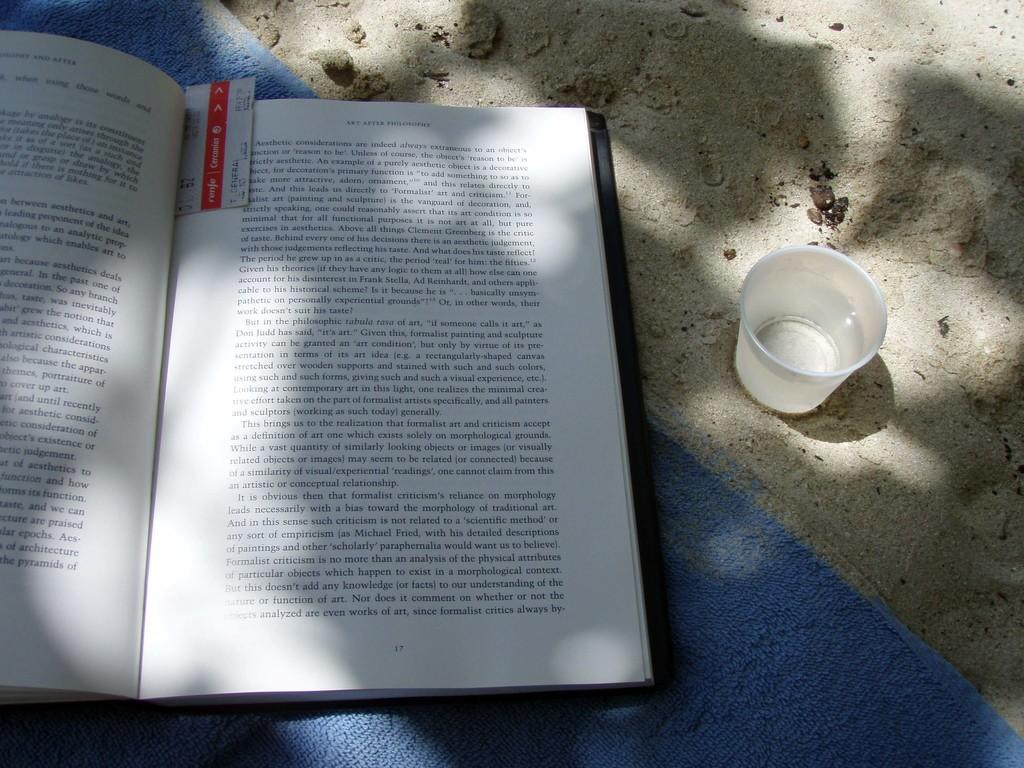<image>
Share a concise interpretation of the image provided. A book that is open to page 17 and has a bookmark in it. 